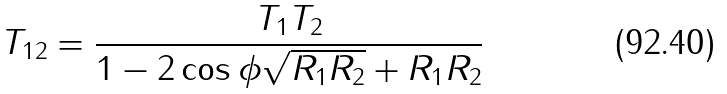<formula> <loc_0><loc_0><loc_500><loc_500>T _ { 1 2 } = \frac { T _ { 1 } T _ { 2 } } { 1 - 2 \cos \phi \sqrt { R _ { 1 } R _ { 2 } } + R _ { 1 } R _ { 2 } }</formula> 